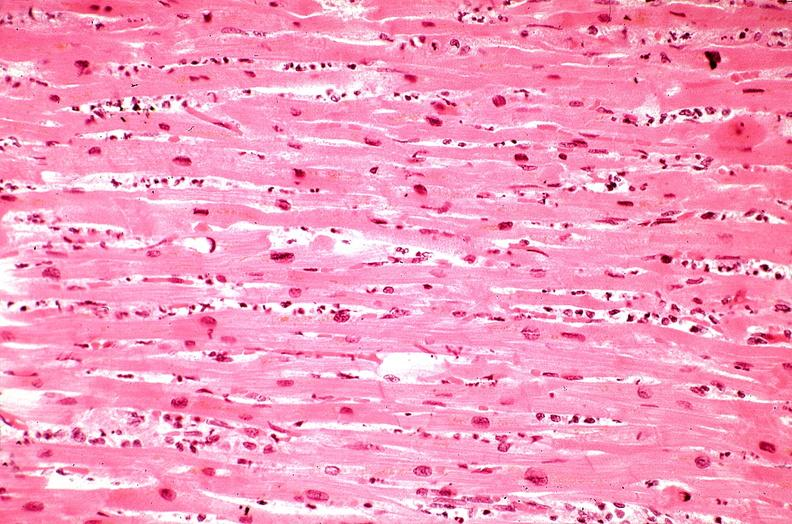what does this image show?
Answer the question using a single word or phrase. Heart 